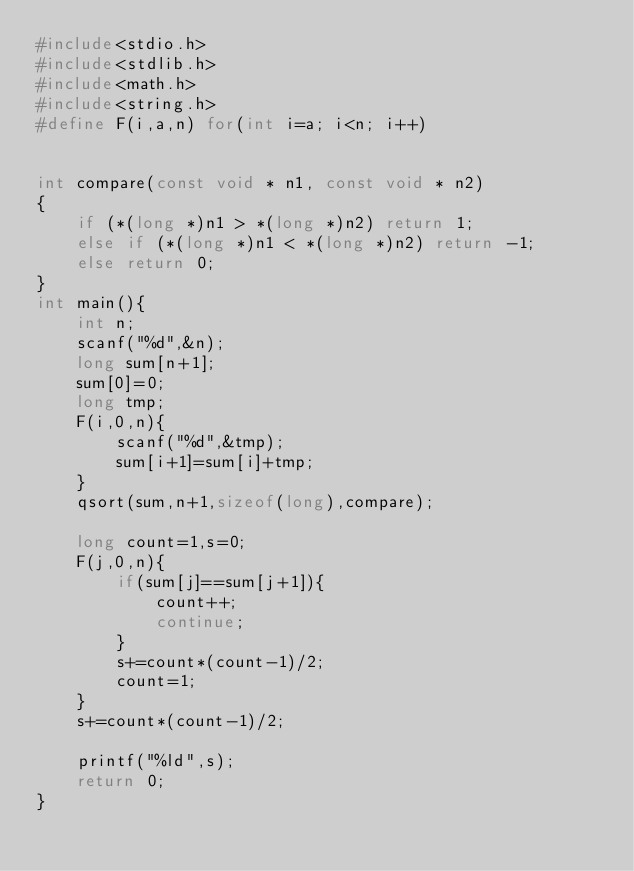Convert code to text. <code><loc_0><loc_0><loc_500><loc_500><_C_>#include<stdio.h>
#include<stdlib.h>
#include<math.h>
#include<string.h>
#define F(i,a,n) for(int i=a; i<n; i++)


int compare(const void * n1, const void * n2)
{
	if (*(long *)n1 > *(long *)n2) return 1;
	else if (*(long *)n1 < *(long *)n2) return -1;
	else return 0;
}
int main(){
    int n;
    scanf("%d",&n);
    long sum[n+1];
    sum[0]=0;
    long tmp;
    F(i,0,n){
        scanf("%d",&tmp);
        sum[i+1]=sum[i]+tmp;
    }
    qsort(sum,n+1,sizeof(long),compare);

    long count=1,s=0;
    F(j,0,n){
        if(sum[j]==sum[j+1]){
            count++;
            continue;
        }
        s+=count*(count-1)/2;
        count=1;
    }
    s+=count*(count-1)/2;

    printf("%ld",s);
    return 0;
}</code> 